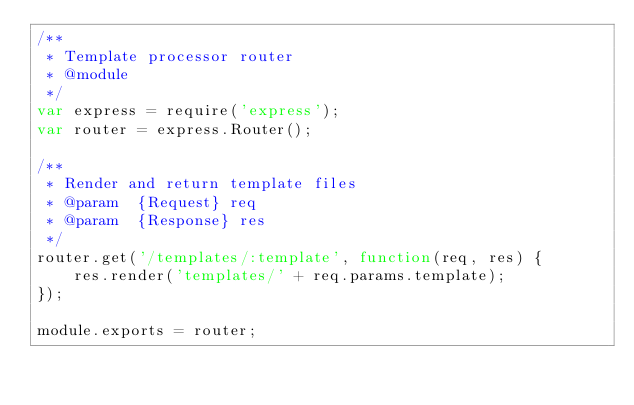<code> <loc_0><loc_0><loc_500><loc_500><_JavaScript_>/**
 * Template processor router
 * @module
 */
var express = require('express');
var router = express.Router();

/**
 * Render and return template files
 * @param  {Request} req
 * @param  {Response} res
 */
router.get('/templates/:template', function(req, res) {
	res.render('templates/' + req.params.template);
});

module.exports = router;</code> 